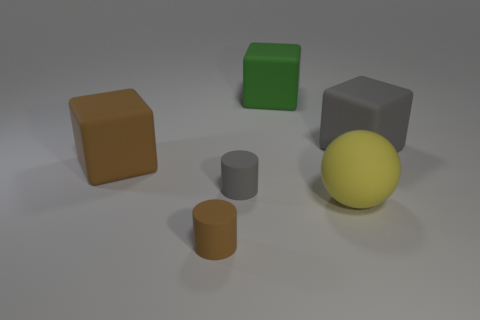Can you tell me the colors of the blocks depicted in the image? Certainly. There are three blocks; one is brown, another is green, and the third is gray. 